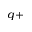Convert formula to latex. <formula><loc_0><loc_0><loc_500><loc_500>^ { q + }</formula> 